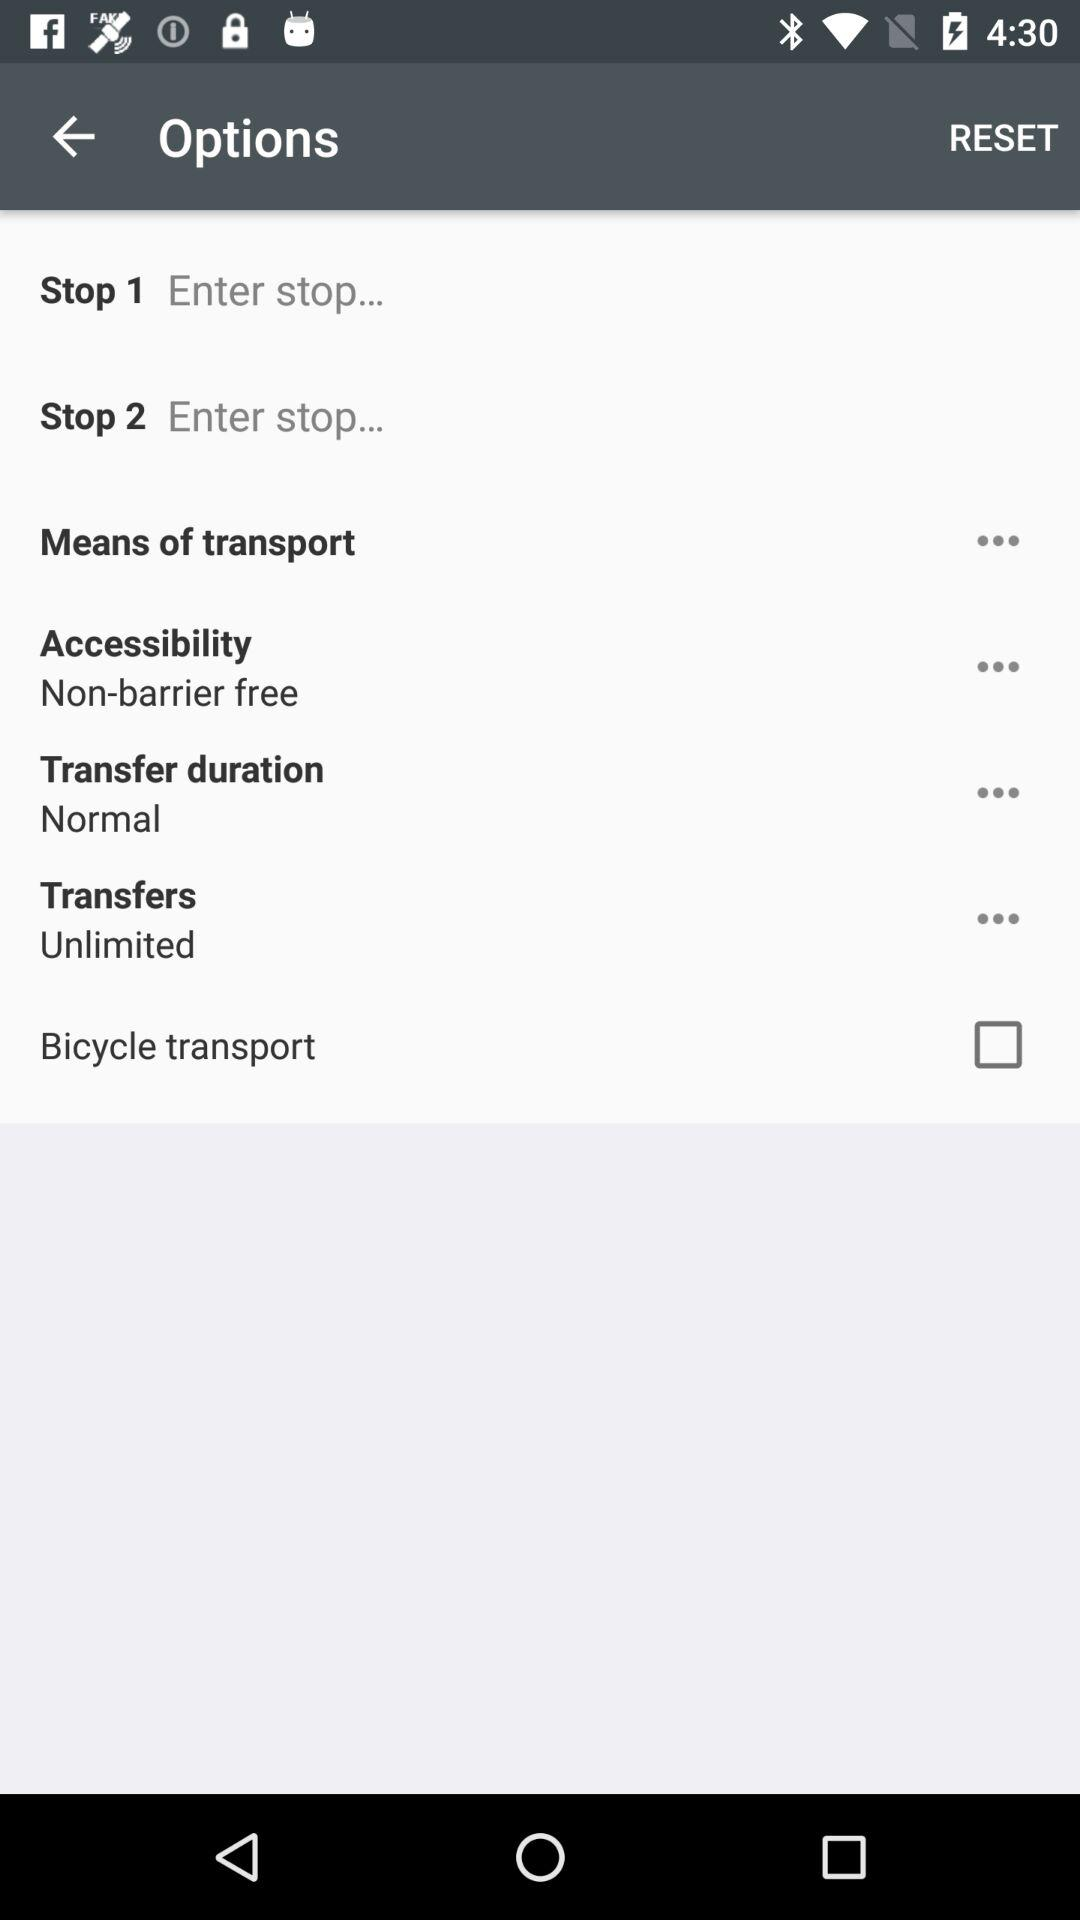How many transfers can I perform? You can perform unlimited transfers. 